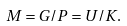Convert formula to latex. <formula><loc_0><loc_0><loc_500><loc_500>M = G / P = U / K .</formula> 